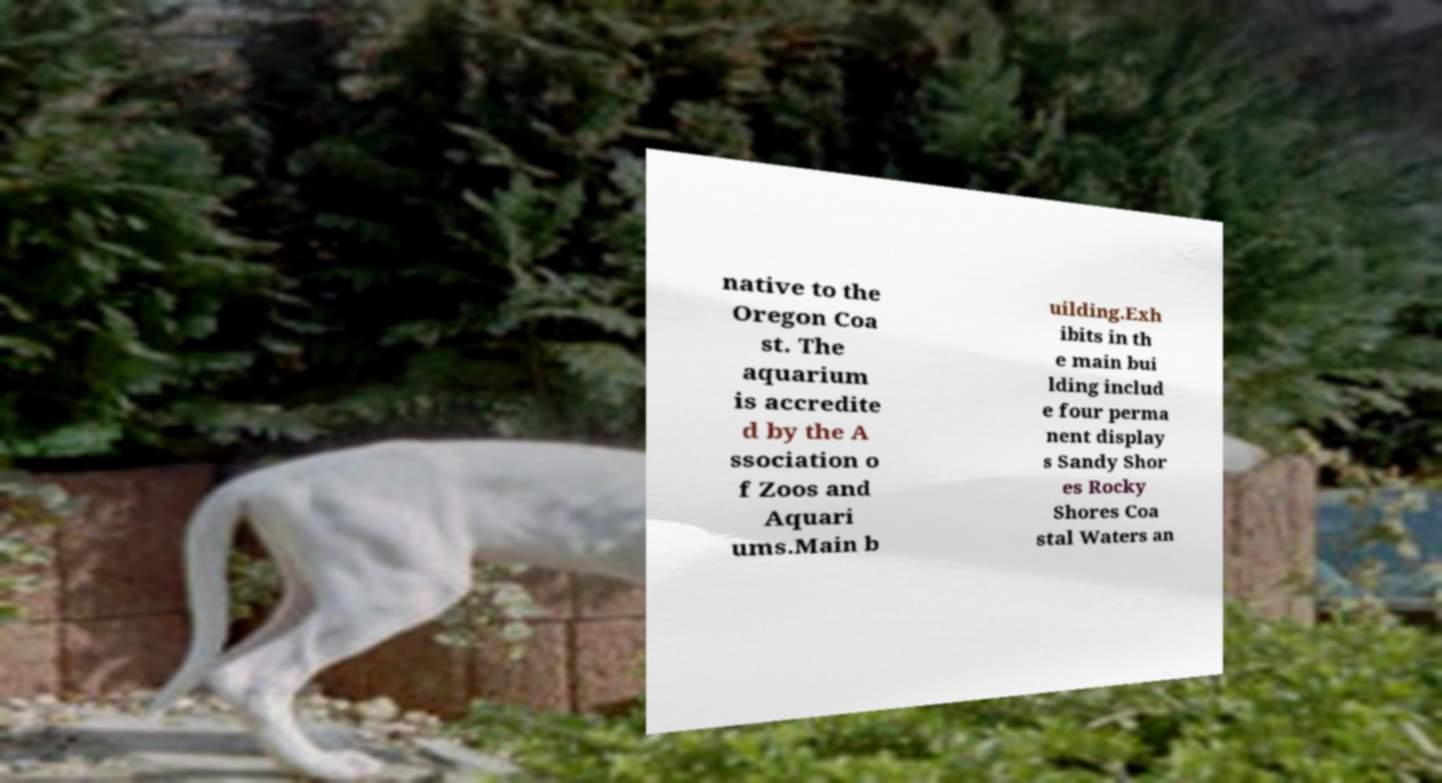Could you extract and type out the text from this image? native to the Oregon Coa st. The aquarium is accredite d by the A ssociation o f Zoos and Aquari ums.Main b uilding.Exh ibits in th e main bui lding includ e four perma nent display s Sandy Shor es Rocky Shores Coa stal Waters an 